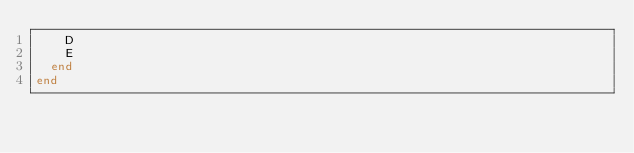<code> <loc_0><loc_0><loc_500><loc_500><_Crystal_>    D
    E
  end
end
</code> 